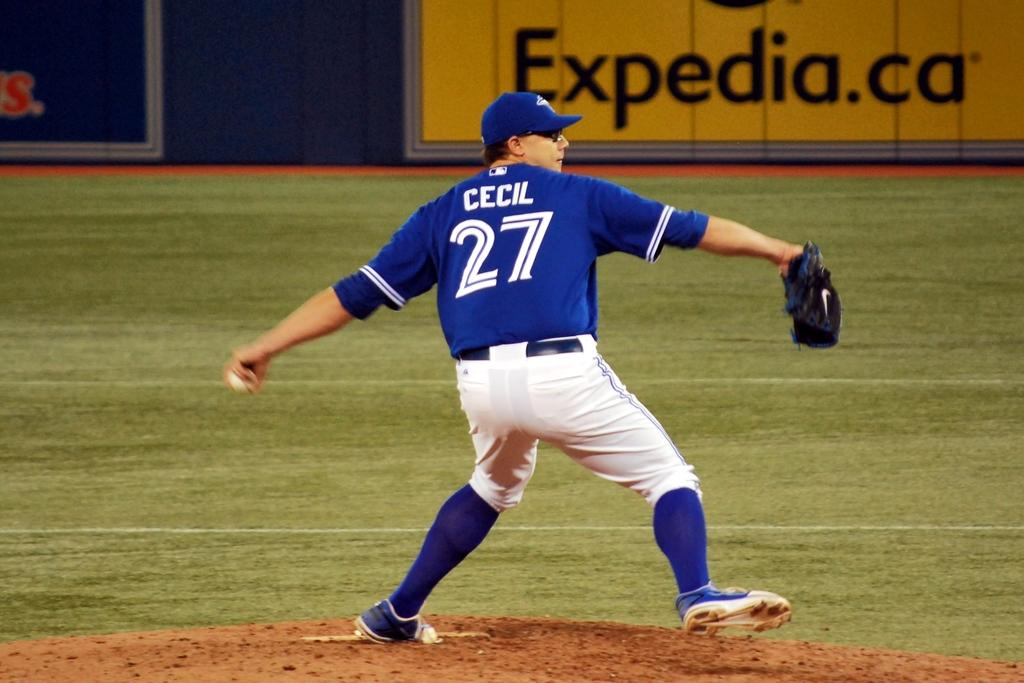<image>
Describe the image concisely. Baseball pitcher from team Toronto swings his arm to throw the ball sponsored by Expedia. 